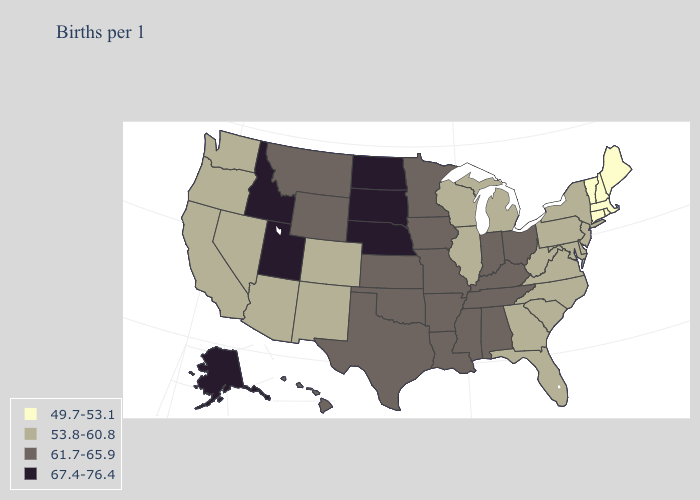What is the highest value in states that border Maryland?
Answer briefly. 53.8-60.8. Name the states that have a value in the range 67.4-76.4?
Give a very brief answer. Alaska, Idaho, Nebraska, North Dakota, South Dakota, Utah. Does Idaho have the lowest value in the USA?
Concise answer only. No. Name the states that have a value in the range 53.8-60.8?
Give a very brief answer. Arizona, California, Colorado, Delaware, Florida, Georgia, Illinois, Maryland, Michigan, Nevada, New Jersey, New Mexico, New York, North Carolina, Oregon, Pennsylvania, South Carolina, Virginia, Washington, West Virginia, Wisconsin. Name the states that have a value in the range 61.7-65.9?
Give a very brief answer. Alabama, Arkansas, Hawaii, Indiana, Iowa, Kansas, Kentucky, Louisiana, Minnesota, Mississippi, Missouri, Montana, Ohio, Oklahoma, Tennessee, Texas, Wyoming. What is the value of North Dakota?
Answer briefly. 67.4-76.4. What is the value of New Hampshire?
Concise answer only. 49.7-53.1. Name the states that have a value in the range 61.7-65.9?
Short answer required. Alabama, Arkansas, Hawaii, Indiana, Iowa, Kansas, Kentucky, Louisiana, Minnesota, Mississippi, Missouri, Montana, Ohio, Oklahoma, Tennessee, Texas, Wyoming. What is the value of Pennsylvania?
Concise answer only. 53.8-60.8. What is the value of Alaska?
Be succinct. 67.4-76.4. Does North Carolina have a lower value than Kansas?
Short answer required. Yes. What is the lowest value in the Northeast?
Short answer required. 49.7-53.1. What is the highest value in states that border Mississippi?
Be succinct. 61.7-65.9. Among the states that border Montana , which have the highest value?
Concise answer only. Idaho, North Dakota, South Dakota. What is the value of Rhode Island?
Answer briefly. 49.7-53.1. 